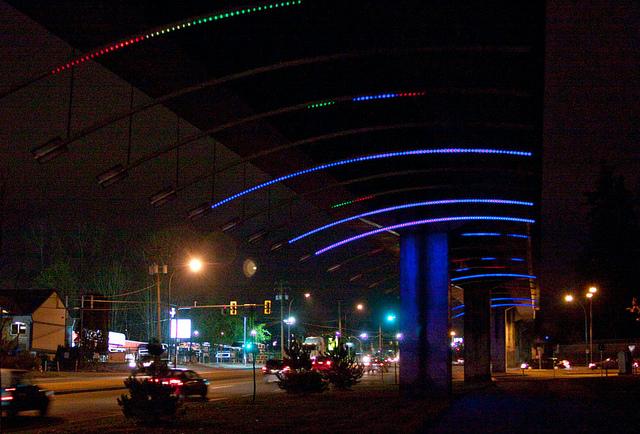Are there blue glowing lights here?
Concise answer only. Yes. Is it day time?
Quick response, please. No. Is this an airport?
Give a very brief answer. No. 